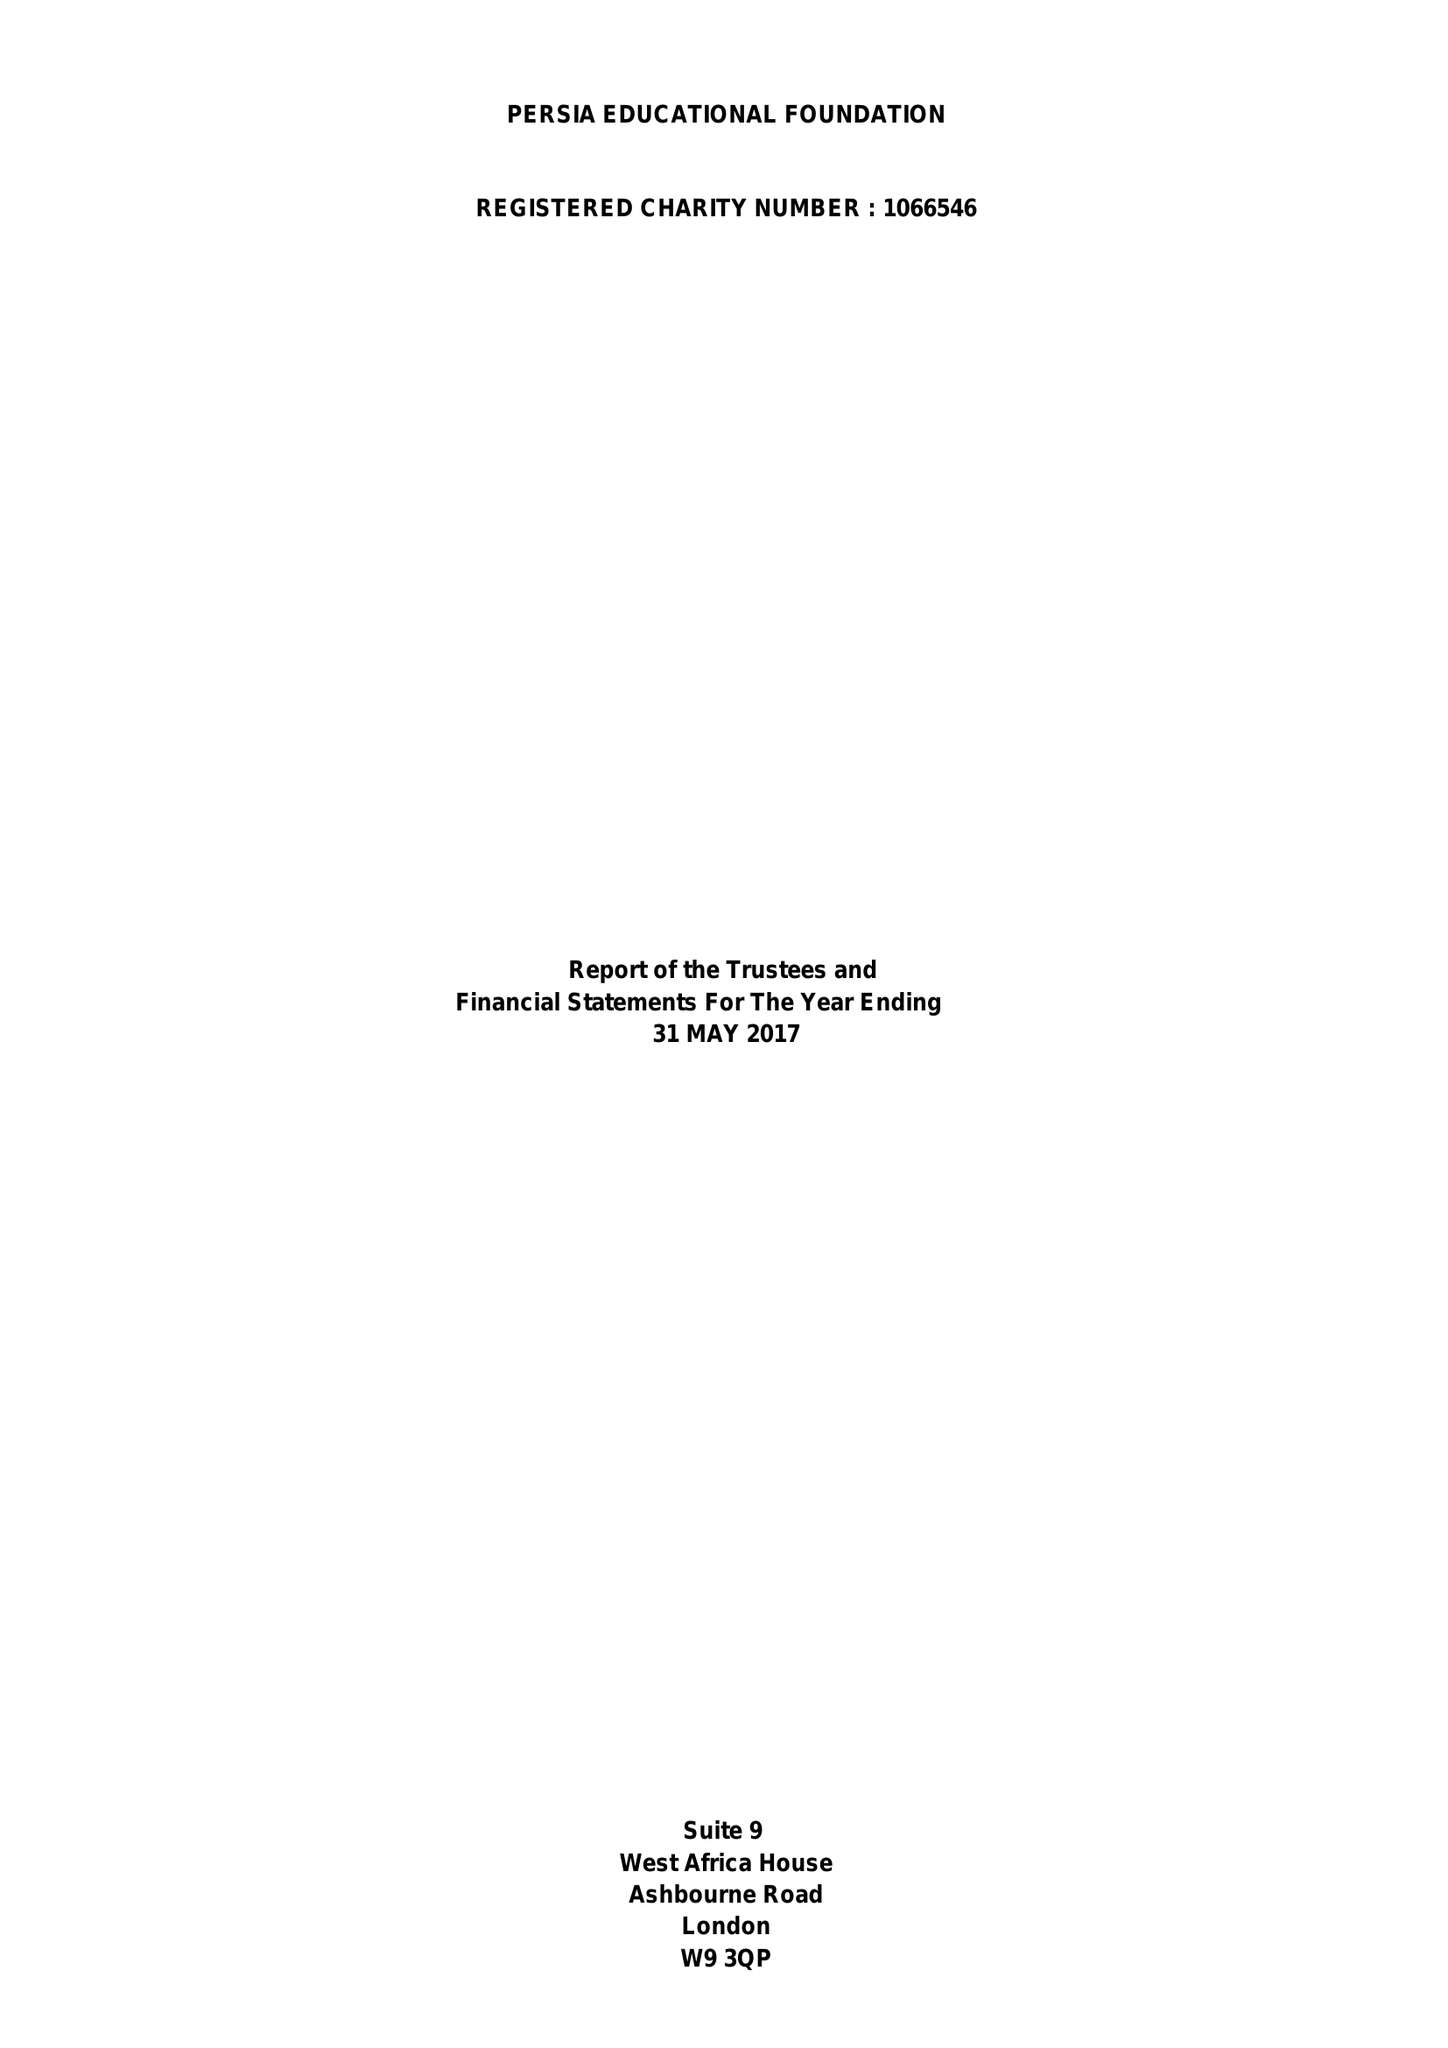What is the value for the report_date?
Answer the question using a single word or phrase. 2017-05-31 